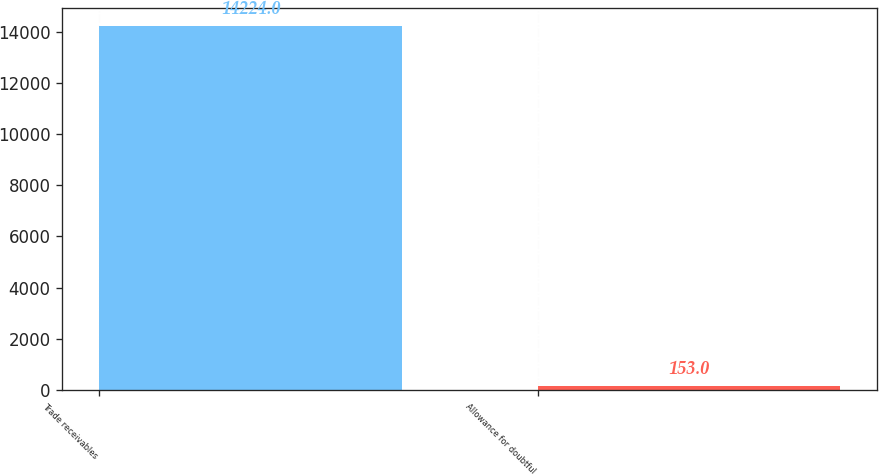<chart> <loc_0><loc_0><loc_500><loc_500><bar_chart><fcel>Trade receivables<fcel>Allowance for doubtful<nl><fcel>14224<fcel>153<nl></chart> 